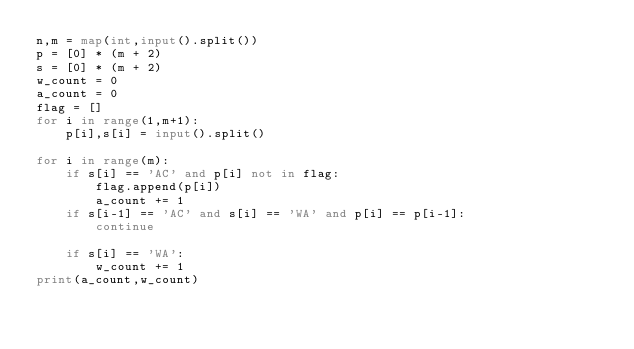<code> <loc_0><loc_0><loc_500><loc_500><_Python_>n,m = map(int,input().split())
p = [0] * (m + 2)
s = [0] * (m + 2)
w_count = 0
a_count = 0
flag = []
for i in range(1,m+1):
    p[i],s[i] = input().split()

for i in range(m):
    if s[i] == 'AC' and p[i] not in flag:
        flag.append(p[i])
        a_count += 1
    if s[i-1] == 'AC' and s[i] == 'WA' and p[i] == p[i-1]:
        continue

    if s[i] == 'WA':
        w_count += 1
print(a_count,w_count)

        
</code> 